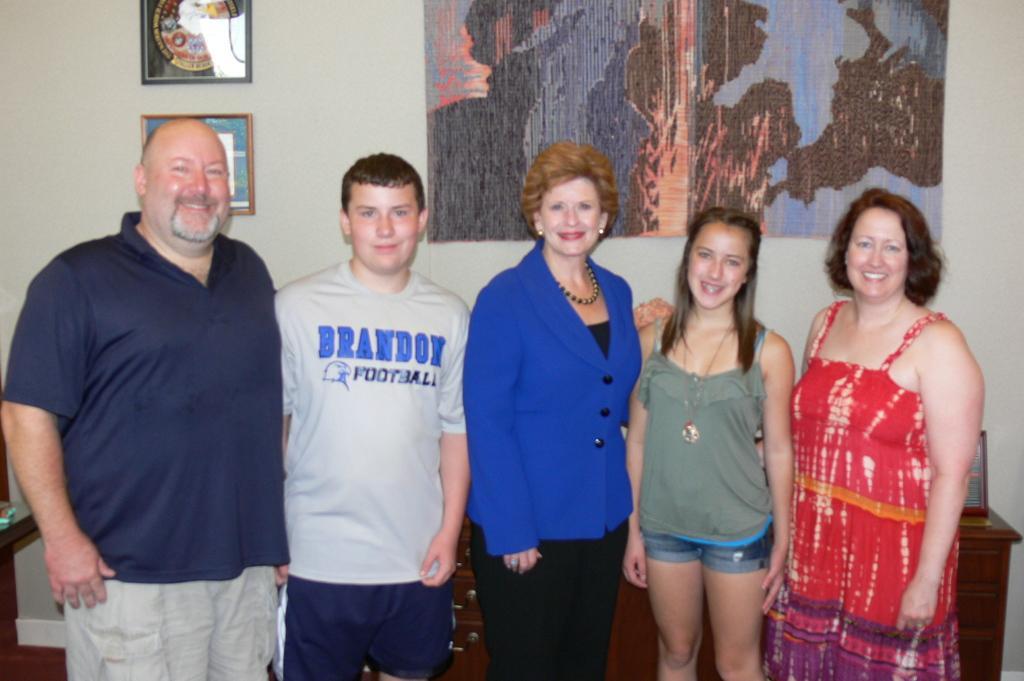In one or two sentences, can you explain what this image depicts? In the image we can see three women and two men standing, wearing clothes and they are smiling. Behind them, we can see the wall and frames stick to the wall, and the middle woman is wearing a neck chain, earrings and finger ring. 